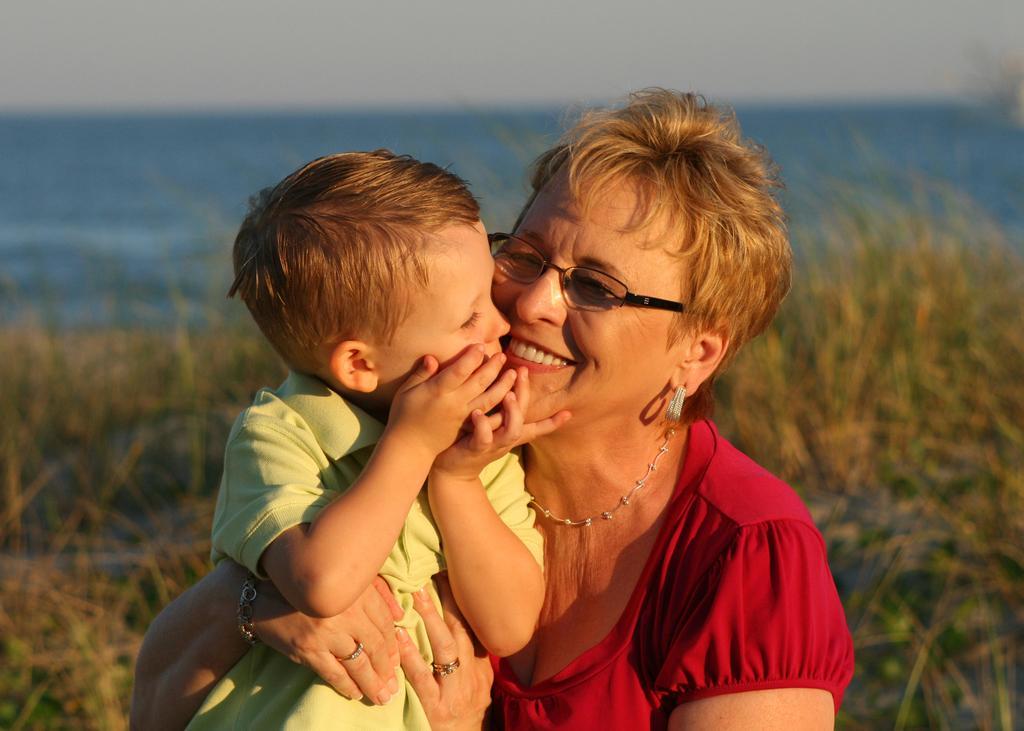How would you summarize this image in a sentence or two? In this image we can see a old lady and a kid. In the background of the image there is grass, water and sky. 